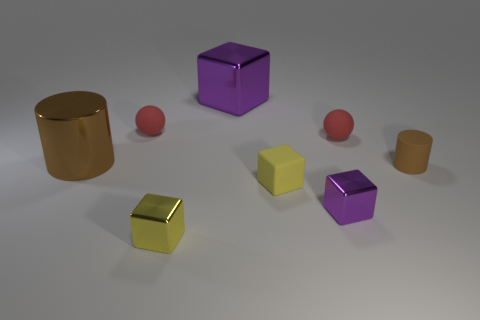Subtract 1 blocks. How many blocks are left? 3 Add 2 brown things. How many objects exist? 10 Subtract all spheres. How many objects are left? 6 Subtract 0 red cylinders. How many objects are left? 8 Subtract all small yellow blocks. Subtract all brown metallic cylinders. How many objects are left? 5 Add 6 large brown shiny objects. How many large brown shiny objects are left? 7 Add 8 purple rubber blocks. How many purple rubber blocks exist? 8 